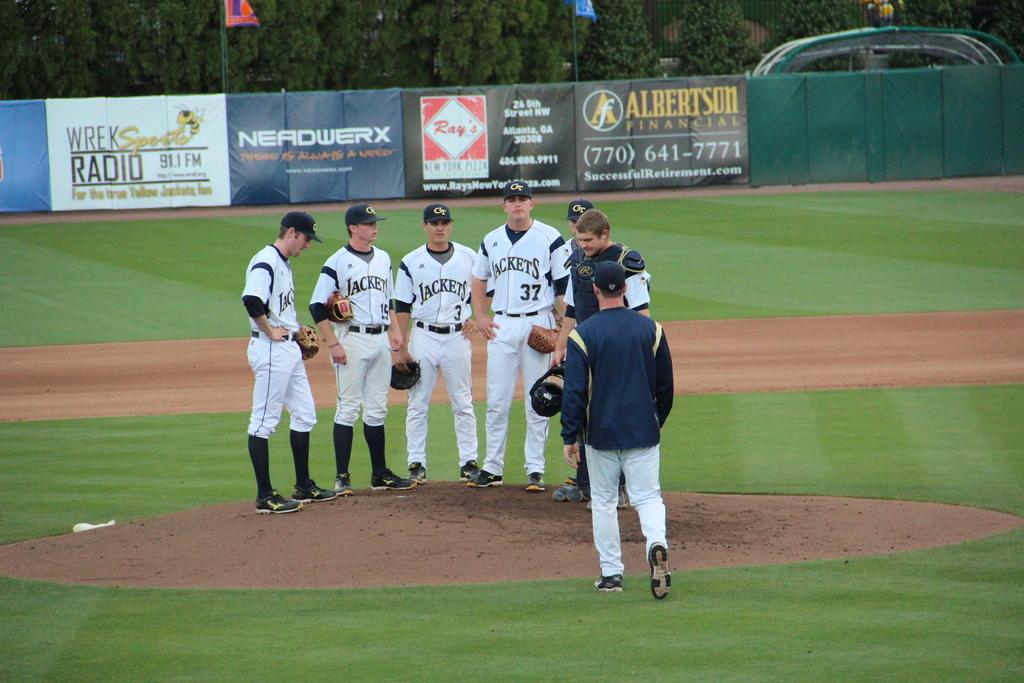<image>
Offer a succinct explanation of the picture presented. Players for the Georgia Tech Yellowjackets have a meeting on the pitcher's mound. 